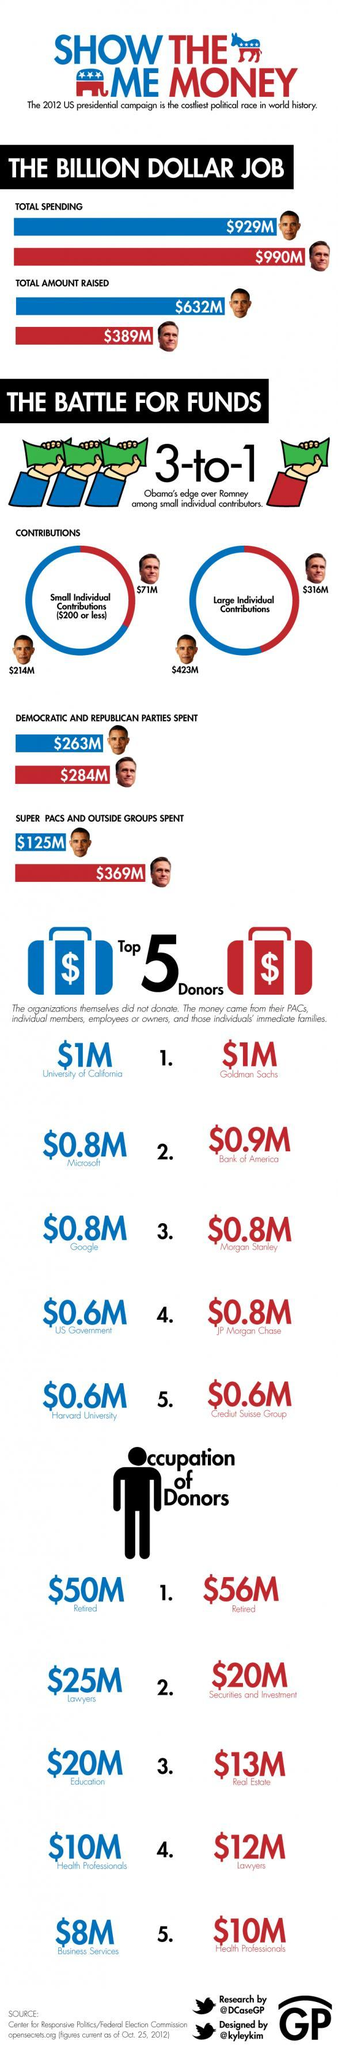What is the amount of money donated by the Bank of America to the Republican party during the 2012 US presidential campaign?
Answer the question with a short phrase. $0.9M How much money did the Republican party spent during the 2012 US presidential campaign? $284M How much money did Mitt Romney raise during the 2012 US presidential campaign? $389M Which organization is the top donor of the democratic party during the 2012 US presidential campaign? University of California How much money is donated by the Microsoft to the Democratic party during the 2012 US presidential campaign? $0.8M How much money did the super pacs & outside groups spent on the democratic party during the 2012 US presidential campaign? $125M What is the total spending on the Barack Obama 2012 presidential campaign? $929M 